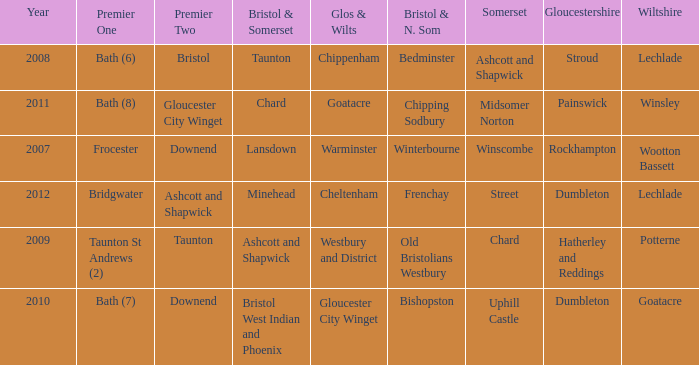Who many times is gloucestershire is painswick? 1.0. 